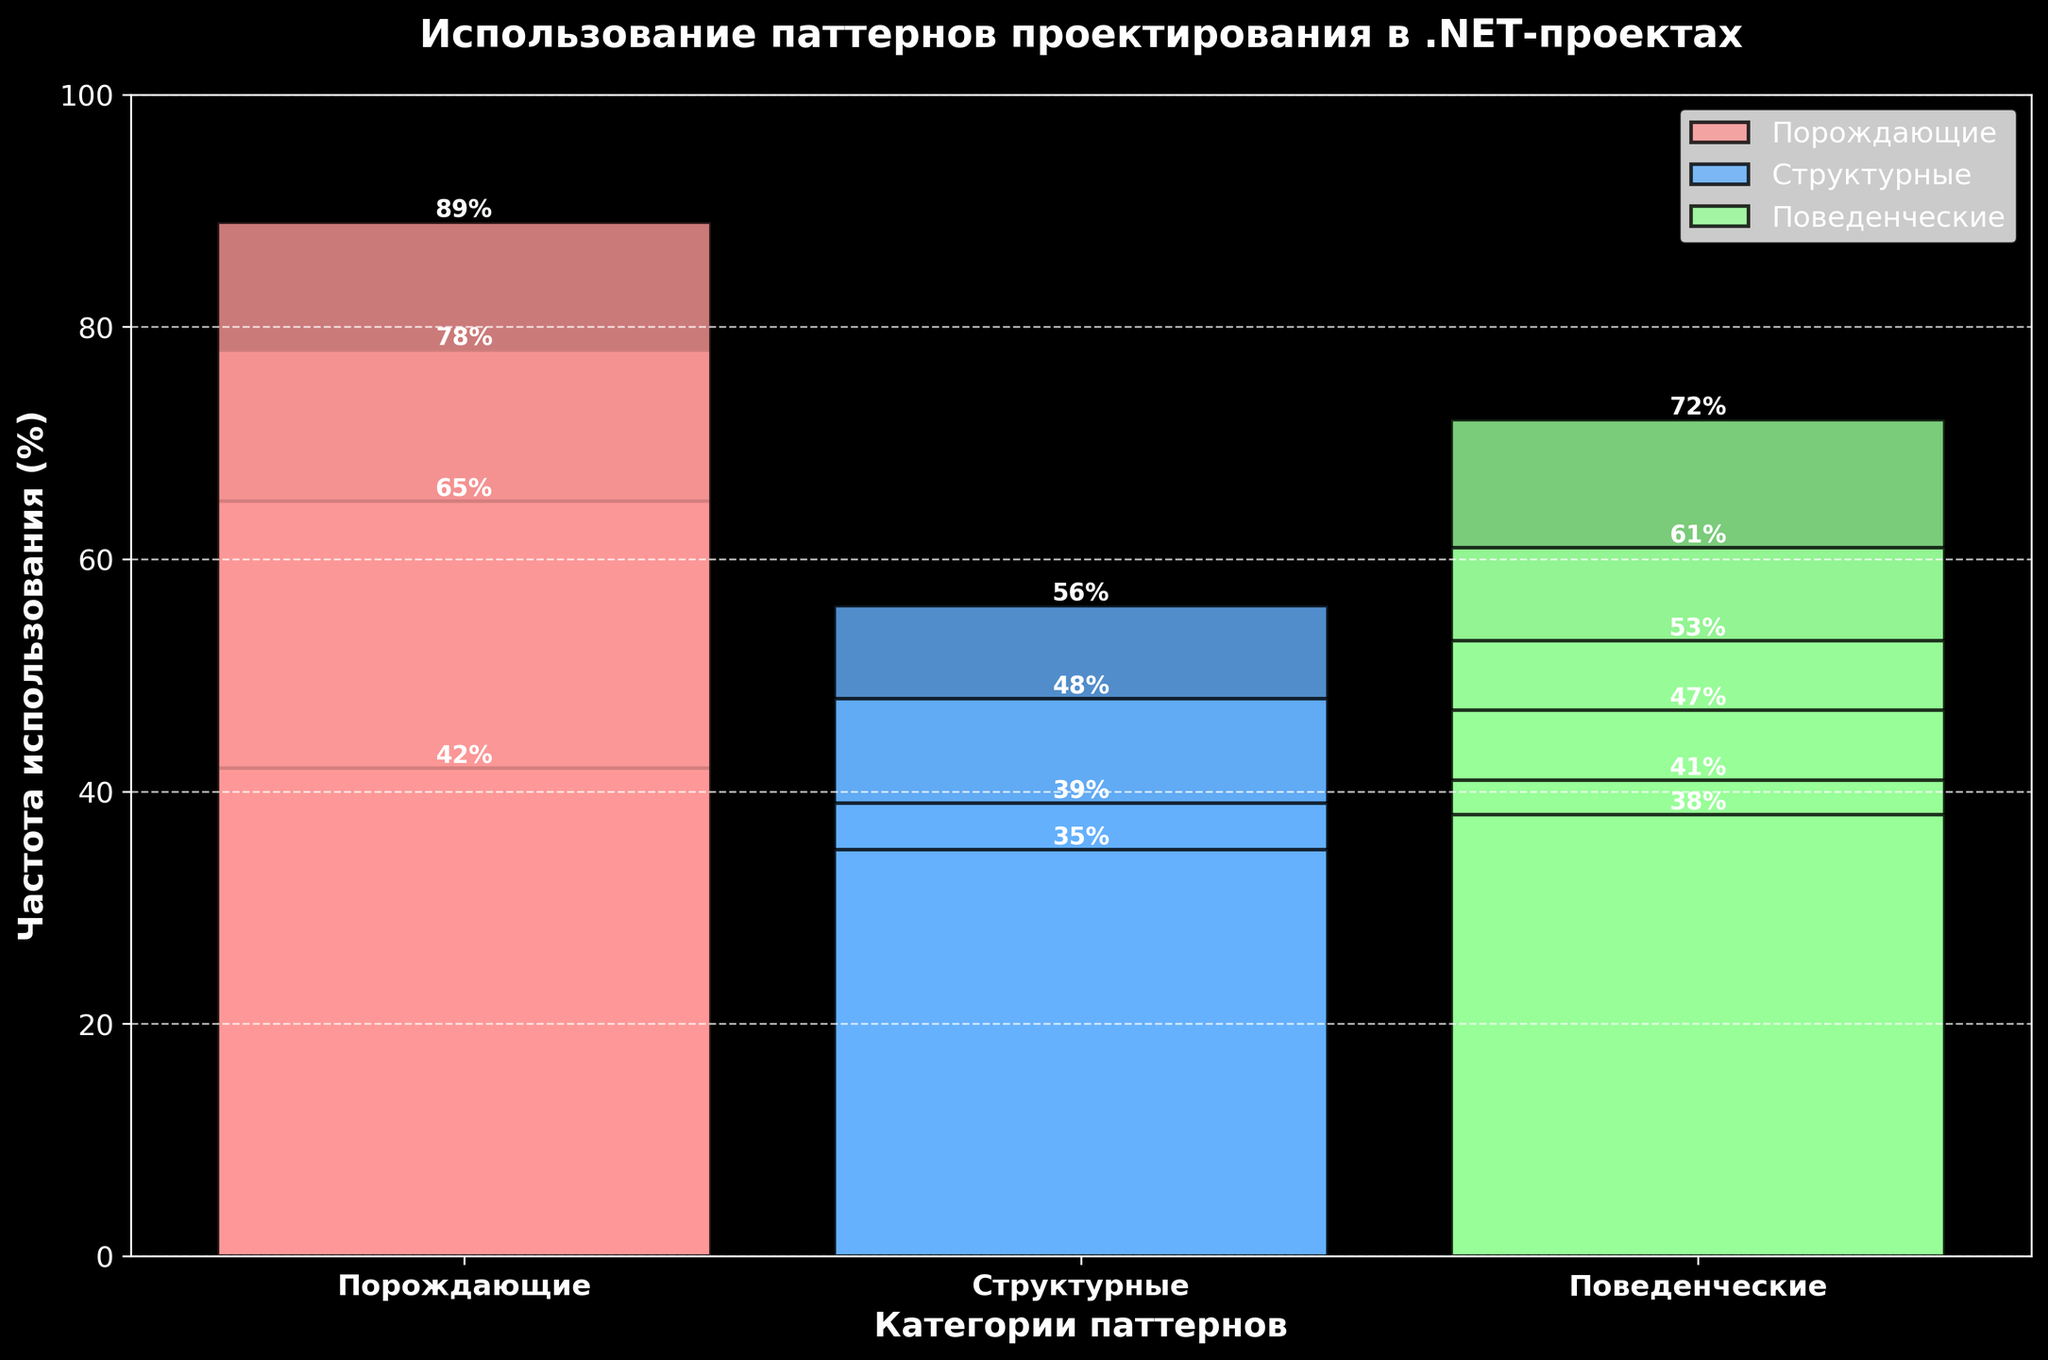Which category has the highest frequency of pattern usage? The bars representing the different categories show their heights. The "Порождающие" category has the highest bars, with "Dependency Injection" having a frequency of 89%.
Answer: Порождающие What is the combined usage percentage for Structurals and Behaviorals? Sum the highest frequency values from Structurals and Behaviorals categories. For Structurals, the highest values are "Adapter" at 56%, "Facade" at 48%, "Decorator" at 39%, and "Proxy" at 35%. For Behaviorals, they are "Observer" at 72%, "Strategy" at 61%, "Command" at 53%, "Template Method" at 47%, "Iterator" at 41%, "State" at 38%. Summing up gives 56 + 48 + 39 + 35 + 72 + 61 + 53 + 47 + 41 + 38.
Answer: 490 Which pattern in the Structurals category is used the least? In the Structurals category, the bar representing "Proxy" is the shortest with a frequency of 35%.
Answer: Proxy Is any pattern in the Behaviorals category used more frequently than the least-used pattern in the Structurals category? Compare all bars in the Behaviorals category with the shortest bar in the Structurals category. "Observer" (72%), "Strategy" (61%), "Command" (53%), "Template Method" (47%), and "Iterator" (41%) all have higher usage percentages than "Proxy" (35%).
Answer: Yes What is the total frequency of usage for all patterns in the Порождающие category? Sum the values for "Singleton" (78%), "Factory Method" (65%), "Builder" (42%), and "Dependency Injection" (89%). Summing up gives 78 + 65 + 42 + 89.
Answer: 274 Which color represents the patterns in the Поведенческие category? The legend indicates the colors corresponding to each category. The patterns in the Поведенческие category are represented by green bars.
Answer: Green Between "Factory Method" and "Strategy", which pattern has a higher frequency of usage? Compare the bars for "Factory Method" from the Порождающие category (65%) and "Strategy" from the Поведенческие category (61%). "Factory Method" has a higher usage frequency.
Answer: Factory Method 